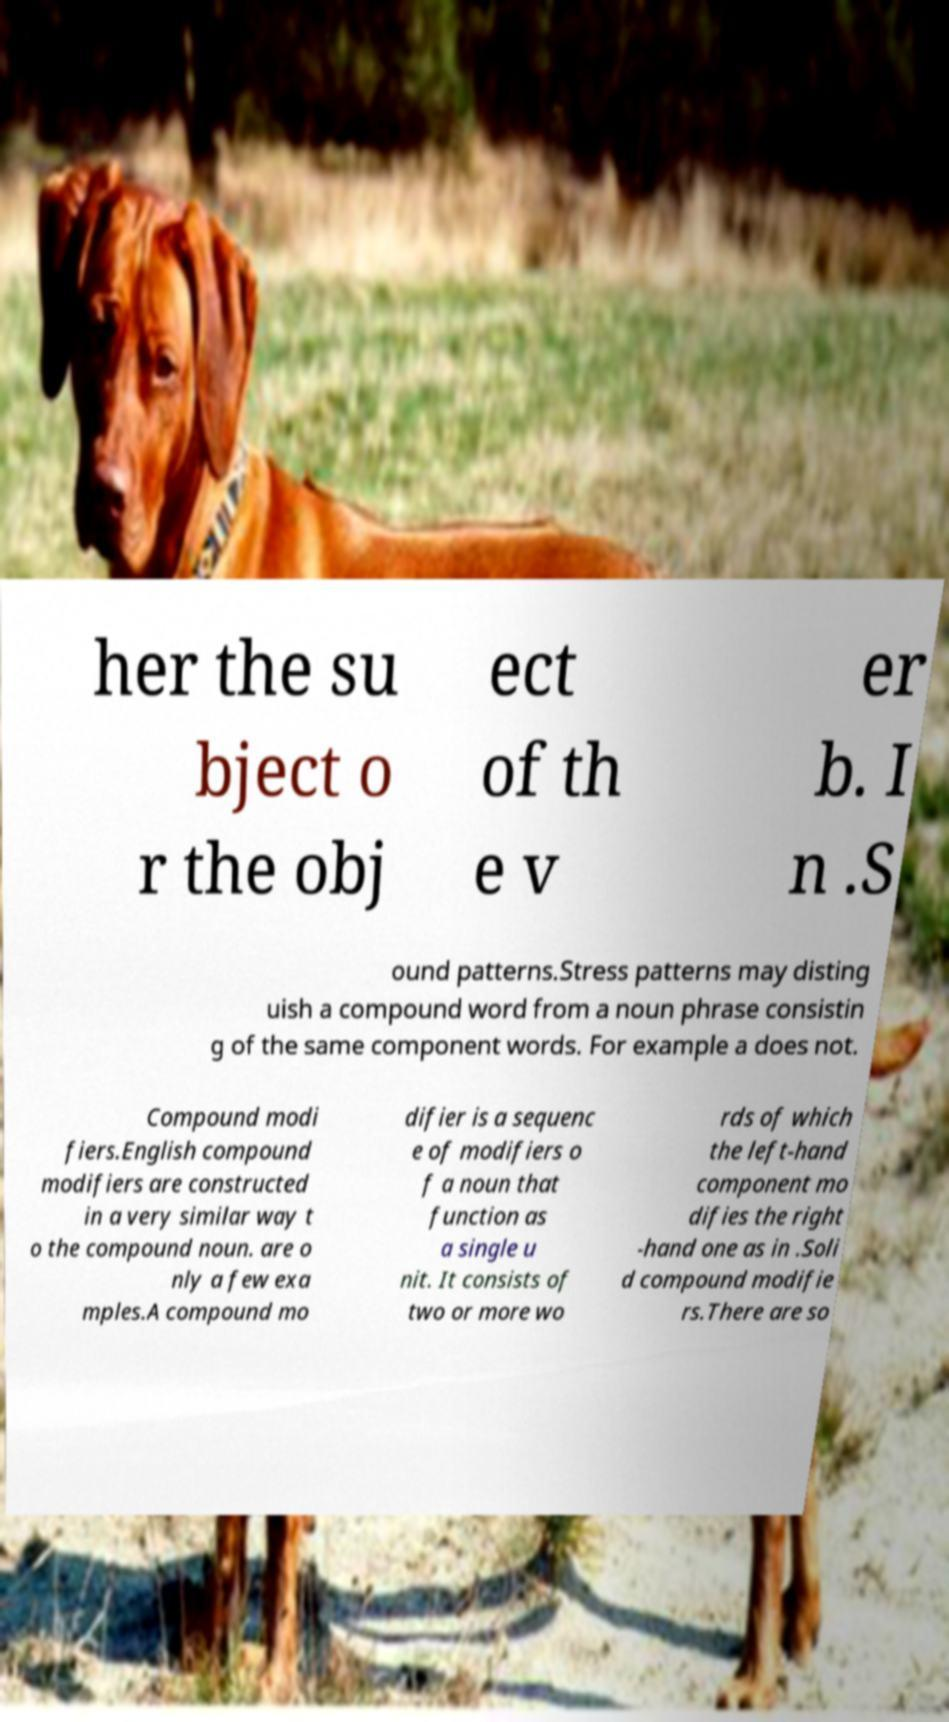Please identify and transcribe the text found in this image. her the su bject o r the obj ect of th e v er b. I n .S ound patterns.Stress patterns may disting uish a compound word from a noun phrase consistin g of the same component words. For example a does not. Compound modi fiers.English compound modifiers are constructed in a very similar way t o the compound noun. are o nly a few exa mples.A compound mo difier is a sequenc e of modifiers o f a noun that function as a single u nit. It consists of two or more wo rds of which the left-hand component mo difies the right -hand one as in .Soli d compound modifie rs.There are so 